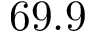<formula> <loc_0><loc_0><loc_500><loc_500>6 9 . 9</formula> 